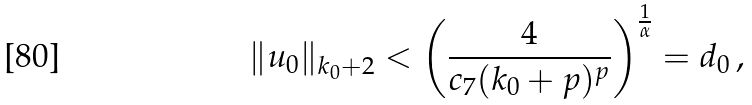Convert formula to latex. <formula><loc_0><loc_0><loc_500><loc_500>\| u _ { 0 } \| _ { k _ { 0 } + 2 } < \left ( \frac { 4 } { c _ { 7 } ( k _ { 0 } + p ) ^ { p } } \right ) ^ { \frac { 1 } { \alpha } } = d _ { 0 } \, ,</formula> 